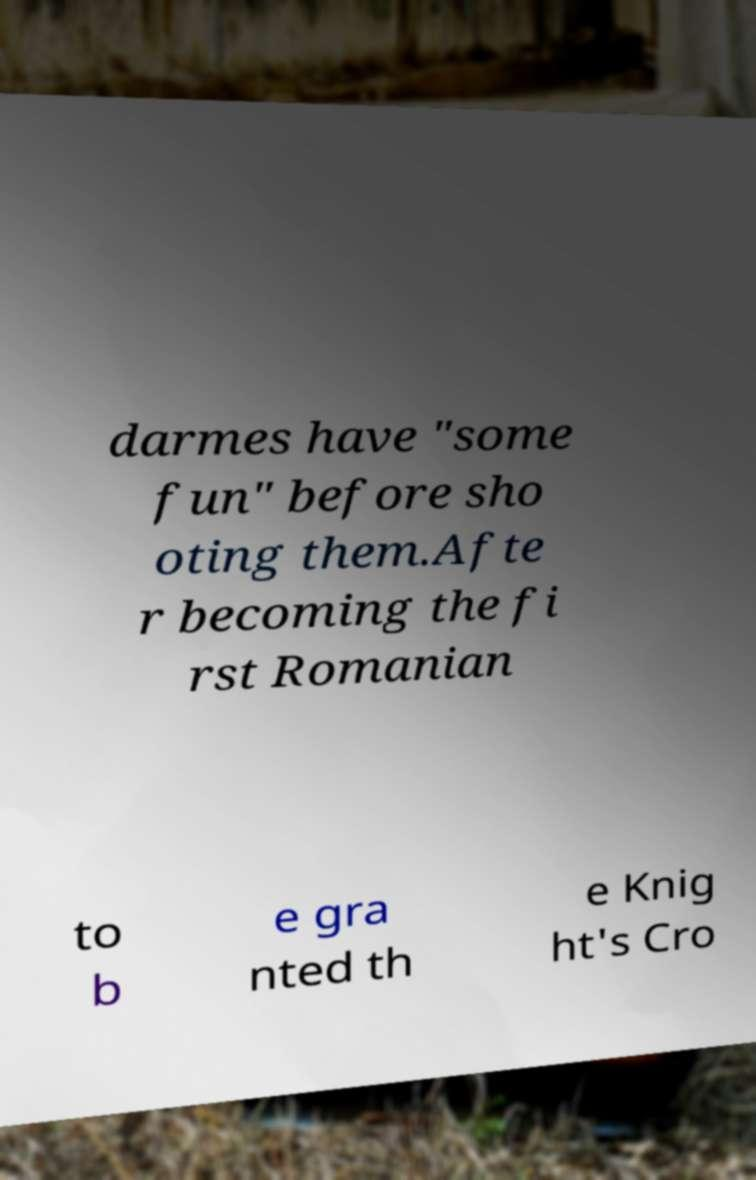Can you read and provide the text displayed in the image?This photo seems to have some interesting text. Can you extract and type it out for me? darmes have "some fun" before sho oting them.Afte r becoming the fi rst Romanian to b e gra nted th e Knig ht's Cro 